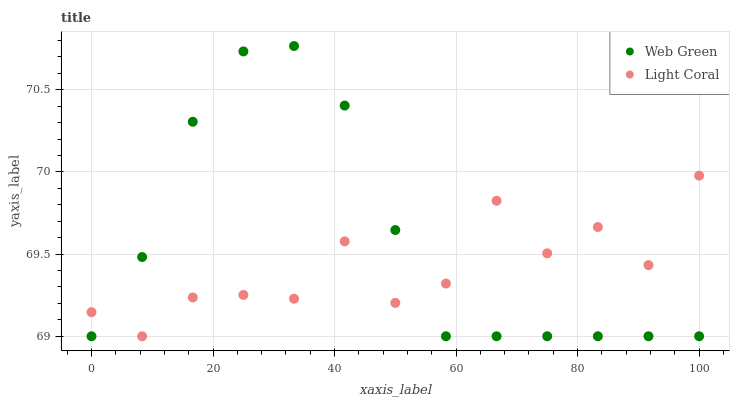Does Light Coral have the minimum area under the curve?
Answer yes or no. Yes. Does Web Green have the maximum area under the curve?
Answer yes or no. Yes. Does Web Green have the minimum area under the curve?
Answer yes or no. No. Is Web Green the smoothest?
Answer yes or no. Yes. Is Light Coral the roughest?
Answer yes or no. Yes. Is Web Green the roughest?
Answer yes or no. No. Does Light Coral have the lowest value?
Answer yes or no. Yes. Does Web Green have the highest value?
Answer yes or no. Yes. Does Light Coral intersect Web Green?
Answer yes or no. Yes. Is Light Coral less than Web Green?
Answer yes or no. No. Is Light Coral greater than Web Green?
Answer yes or no. No. 